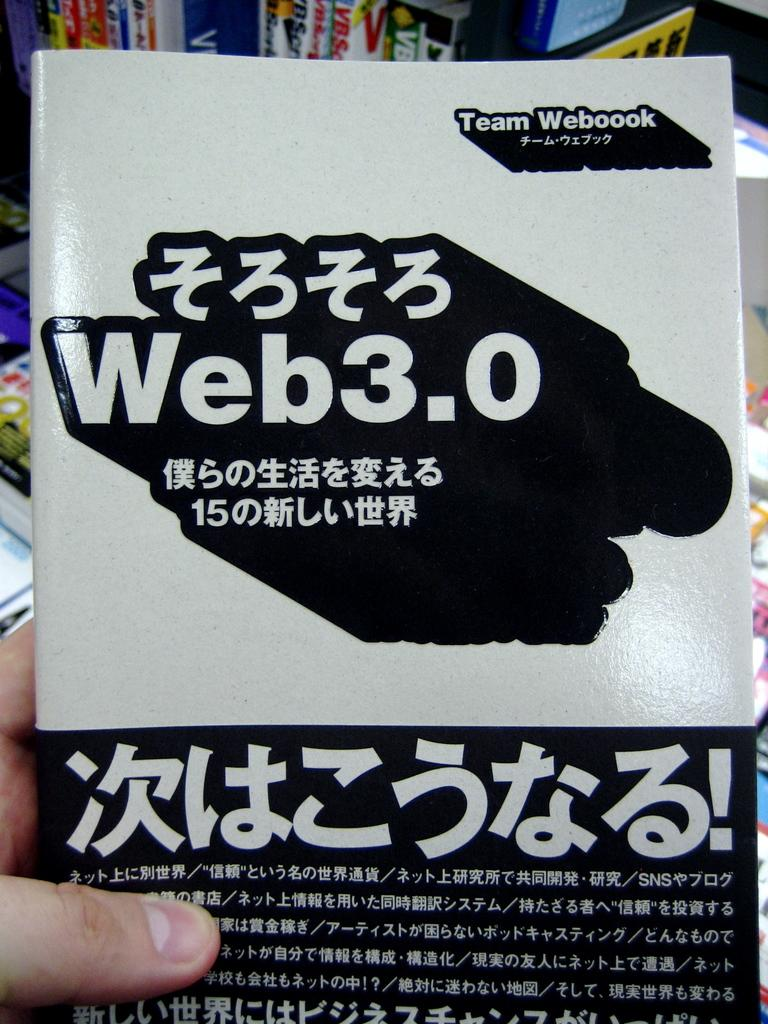<image>
Create a compact narrative representing the image presented. A person is holding a booklet that is titled Web 3.0. 